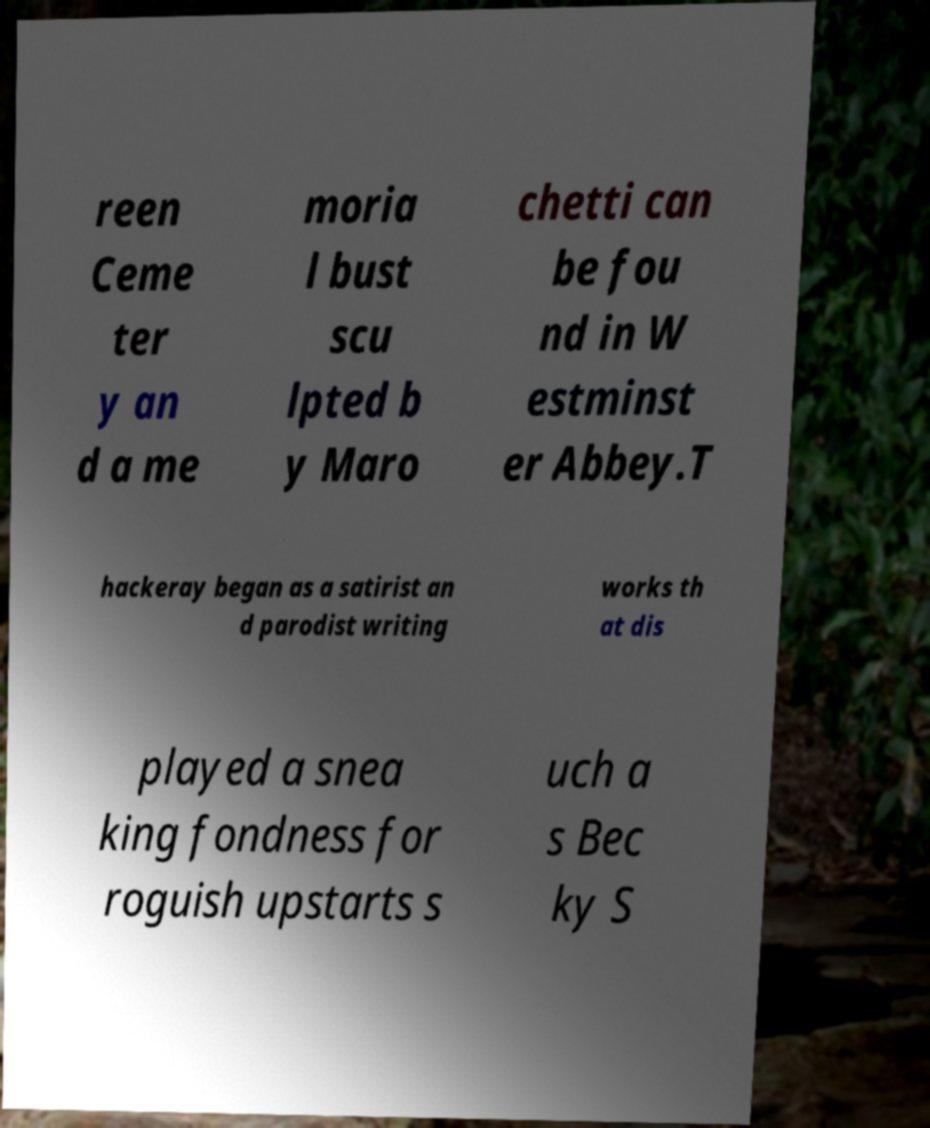Could you assist in decoding the text presented in this image and type it out clearly? reen Ceme ter y an d a me moria l bust scu lpted b y Maro chetti can be fou nd in W estminst er Abbey.T hackeray began as a satirist an d parodist writing works th at dis played a snea king fondness for roguish upstarts s uch a s Bec ky S 